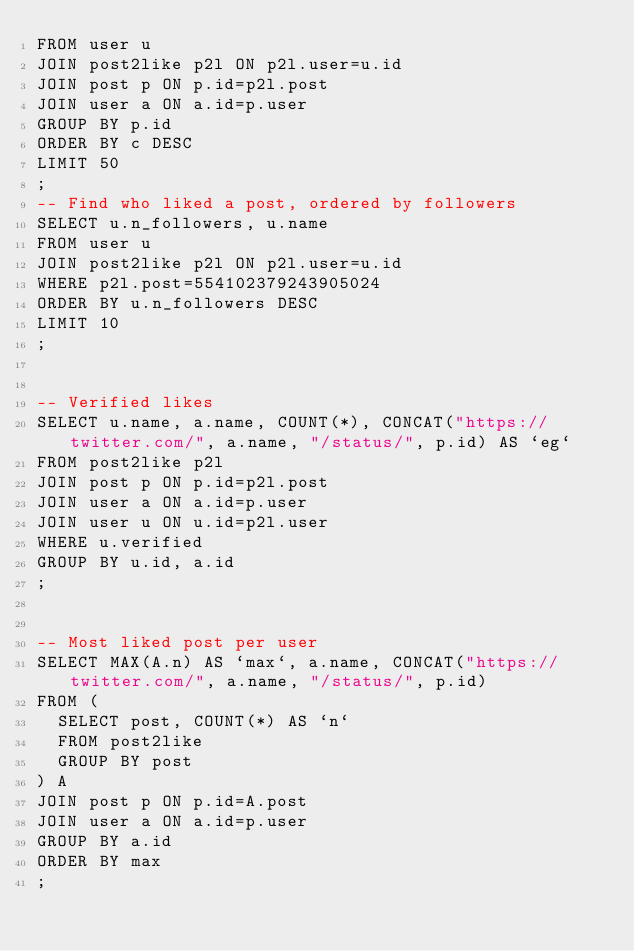<code> <loc_0><loc_0><loc_500><loc_500><_SQL_>FROM user u
JOIN post2like p2l ON p2l.user=u.id
JOIN post p ON p.id=p2l.post
JOIN user a ON a.id=p.user
GROUP BY p.id
ORDER BY c DESC
LIMIT 50
;
-- Find who liked a post, ordered by followers
SELECT u.n_followers, u.name
FROM user u
JOIN post2like p2l ON p2l.user=u.id
WHERE p2l.post=554102379243905024
ORDER BY u.n_followers DESC
LIMIT 10
;


-- Verified likes
SELECT u.name, a.name, COUNT(*), CONCAT("https://twitter.com/", a.name, "/status/", p.id) AS `eg`
FROM post2like p2l
JOIN post p ON p.id=p2l.post
JOIN user a ON a.id=p.user
JOIN user u ON u.id=p2l.user
WHERE u.verified
GROUP BY u.id, a.id
;


-- Most liked post per user
SELECT MAX(A.n) AS `max`, a.name, CONCAT("https://twitter.com/", a.name, "/status/", p.id)
FROM (
	SELECT post, COUNT(*) AS `n`
	FROM post2like
	GROUP BY post
) A
JOIN post p ON p.id=A.post
JOIN user a ON a.id=p.user
GROUP BY a.id
ORDER BY max
;
</code> 